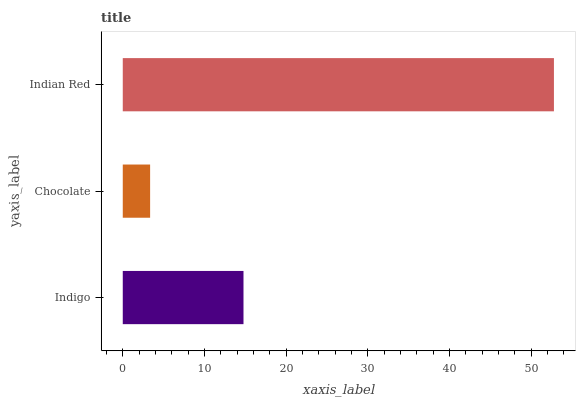Is Chocolate the minimum?
Answer yes or no. Yes. Is Indian Red the maximum?
Answer yes or no. Yes. Is Indian Red the minimum?
Answer yes or no. No. Is Chocolate the maximum?
Answer yes or no. No. Is Indian Red greater than Chocolate?
Answer yes or no. Yes. Is Chocolate less than Indian Red?
Answer yes or no. Yes. Is Chocolate greater than Indian Red?
Answer yes or no. No. Is Indian Red less than Chocolate?
Answer yes or no. No. Is Indigo the high median?
Answer yes or no. Yes. Is Indigo the low median?
Answer yes or no. Yes. Is Indian Red the high median?
Answer yes or no. No. Is Chocolate the low median?
Answer yes or no. No. 